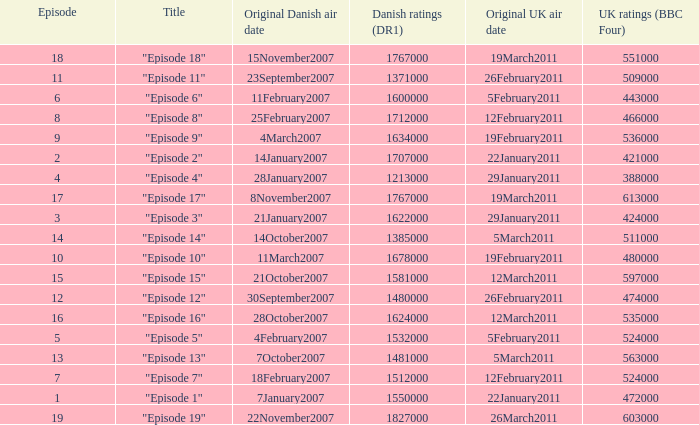What is the original Danish air date of "Episode 17"?  8November2007. 